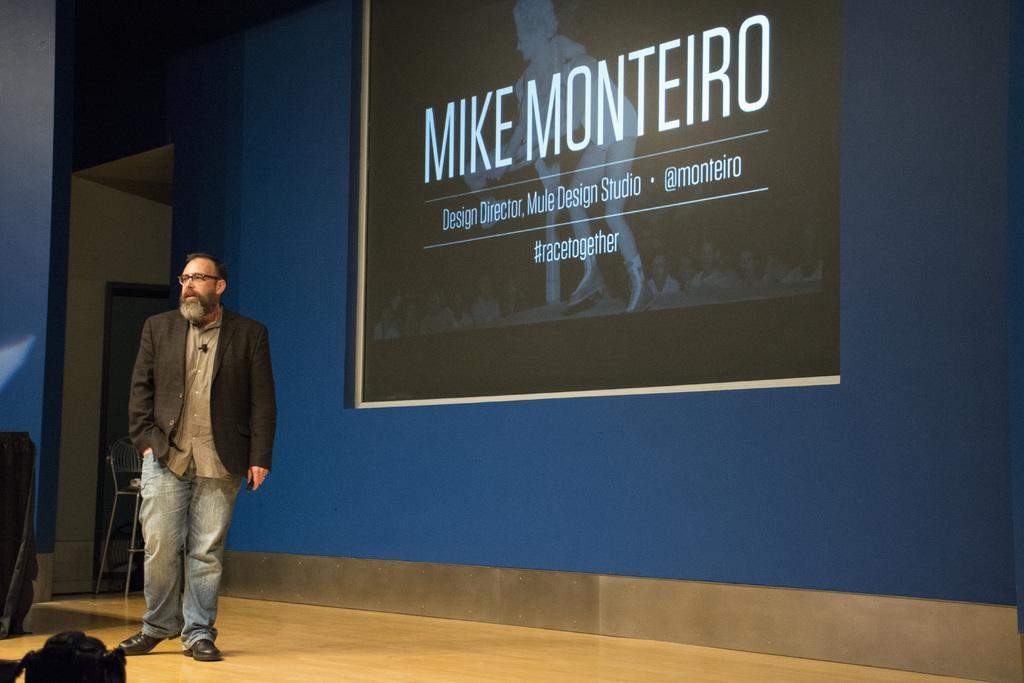Please provide a concise description of this image. In this image we can see a person wearing a black coat and spectacle is standing on the floor. In the background ,we can see a chair placed in the ground and a screen on the wall. 